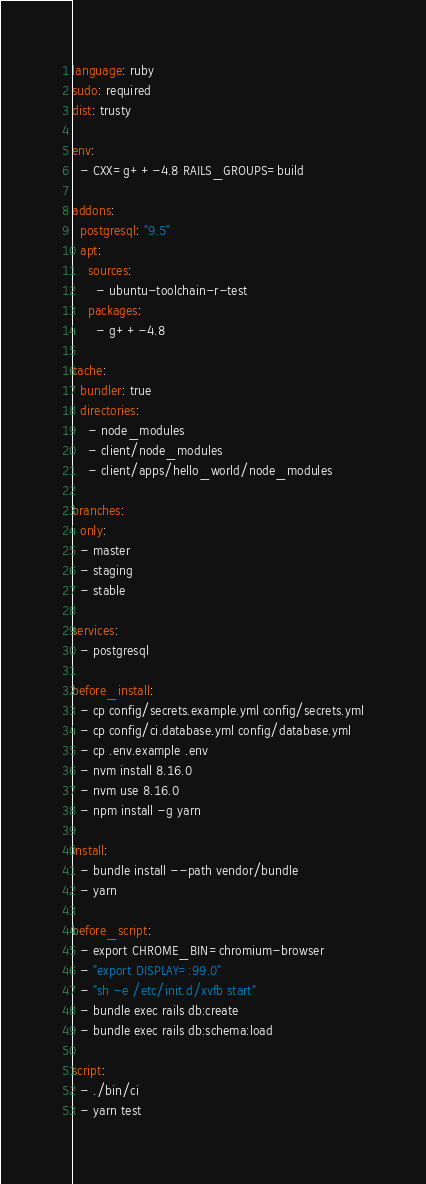Convert code to text. <code><loc_0><loc_0><loc_500><loc_500><_YAML_>language: ruby
sudo: required
dist: trusty

env:
  - CXX=g++-4.8 RAILS_GROUPS=build

addons:
  postgresql: "9.5"
  apt:
    sources:
      - ubuntu-toolchain-r-test
    packages:
      - g++-4.8

cache:
  bundler: true
  directories:
    - node_modules
    - client/node_modules
    - client/apps/hello_world/node_modules

branches:
  only:
  - master
  - staging
  - stable

services:
  - postgresql

before_install:
  - cp config/secrets.example.yml config/secrets.yml
  - cp config/ci.database.yml config/database.yml
  - cp .env.example .env
  - nvm install 8.16.0
  - nvm use 8.16.0
  - npm install -g yarn

install:
  - bundle install --path vendor/bundle
  - yarn

before_script:
  - export CHROME_BIN=chromium-browser
  - "export DISPLAY=:99.0"
  - "sh -e /etc/init.d/xvfb start"
  - bundle exec rails db:create
  - bundle exec rails db:schema:load

script:
  - ./bin/ci
  - yarn test
</code> 